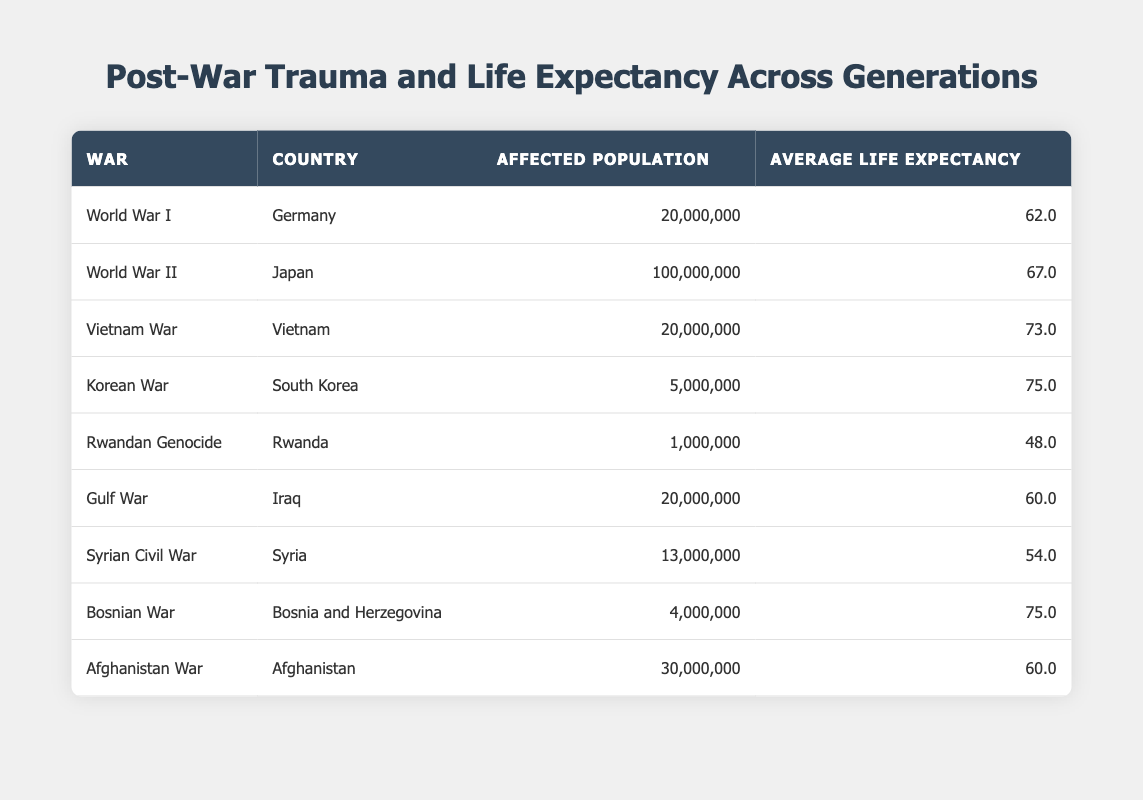What is the average life expectancy for countries affected by World War II? From the table, the only country listed under World War II is Japan, with an average life expectancy of 67.0 years. Therefore, the average life expectancy for countries affected by World War II is simply 67.0 years.
Answer: 67.0 Which country has the highest average life expectancy in this table? The table lists the average life expectancy for different countries. The maximum value is 75.0 years for both South Korea (Korean War) and Bosnia and Herzegovina (Bosnian War). Therefore, they both share the highest average life expectancy.
Answer: South Korea and Bosnia and Herzegovina What is the total affected population for the wars listed? To find the total affected population across all the wars, add each affected population figure: 20,000,000 (WWI) + 100,000,000 (WWII) + 20,000,000 (Vietnam War) + 5,000,000 (Korean War) + 1,000,000 (Rwandan Genocide) + 20,000,000 (Gulf War) + 13,000,000 (Syrian Civil War) + 4,000,000 (Bosnian War) + 30,000,000 (Afghanistan War) = 213,000,000.
Answer: 213,000,000 Is the average life expectancy for Iraq higher than that for Rwanda? Iraq has an average life expectancy of 60.0 years while Rwanda has 48.0 years, which means Iraq's average life expectancy is indeed higher than Rwanda's.
Answer: Yes What is the difference in life expectancy between the Korean War and the Rwandan Genocide? The life expectancy for South Korea (Korean War) is 75.0 years, and for Rwanda (Rwandan Genocide) it is 48.0 years. The difference is calculated as 75.0 - 48.0 = 27.0.
Answer: 27.0 